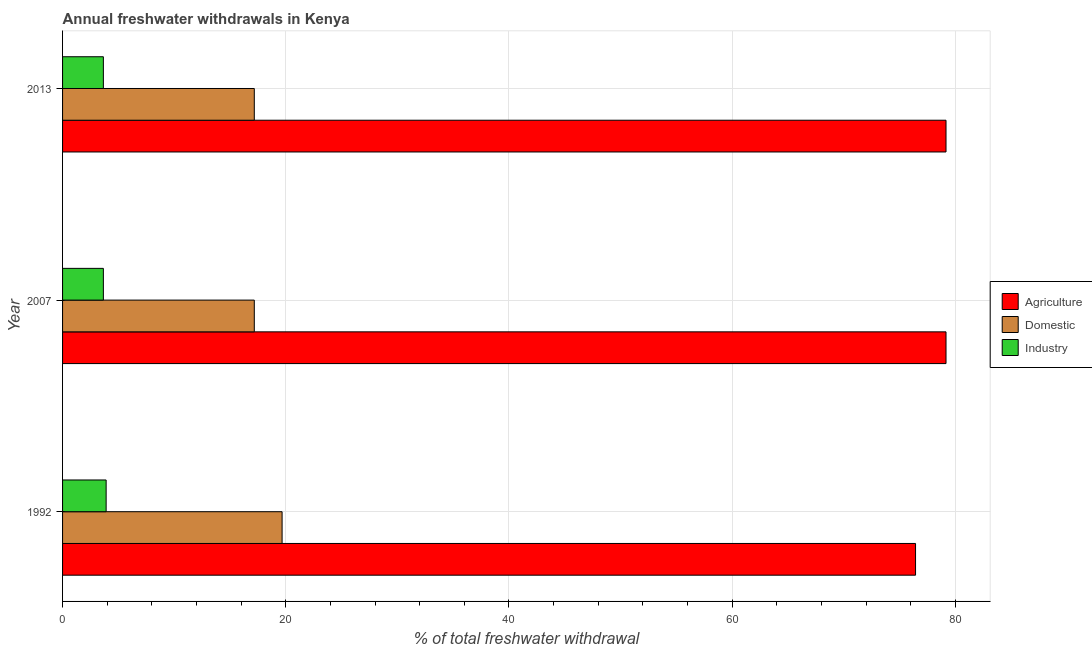Are the number of bars per tick equal to the number of legend labels?
Keep it short and to the point. Yes. Are the number of bars on each tick of the Y-axis equal?
Offer a terse response. Yes. How many bars are there on the 3rd tick from the top?
Provide a succinct answer. 3. How many bars are there on the 3rd tick from the bottom?
Provide a short and direct response. 3. What is the label of the 2nd group of bars from the top?
Your answer should be very brief. 2007. In how many cases, is the number of bars for a given year not equal to the number of legend labels?
Offer a terse response. 0. What is the percentage of freshwater withdrawal for industry in 2013?
Make the answer very short. 3.66. Across all years, what is the maximum percentage of freshwater withdrawal for agriculture?
Provide a short and direct response. 79.16. Across all years, what is the minimum percentage of freshwater withdrawal for agriculture?
Keep it short and to the point. 76.43. In which year was the percentage of freshwater withdrawal for domestic purposes minimum?
Make the answer very short. 2007. What is the total percentage of freshwater withdrawal for domestic purposes in the graph?
Your answer should be compact. 54.03. What is the difference between the percentage of freshwater withdrawal for industry in 1992 and that in 2007?
Provide a succinct answer. 0.25. What is the difference between the percentage of freshwater withdrawal for domestic purposes in 1992 and the percentage of freshwater withdrawal for agriculture in 2007?
Give a very brief answer. -59.49. What is the average percentage of freshwater withdrawal for industry per year?
Keep it short and to the point. 3.74. In the year 1992, what is the difference between the percentage of freshwater withdrawal for industry and percentage of freshwater withdrawal for domestic purposes?
Ensure brevity in your answer.  -15.77. Is the difference between the percentage of freshwater withdrawal for domestic purposes in 1992 and 2007 greater than the difference between the percentage of freshwater withdrawal for industry in 1992 and 2007?
Your response must be concise. Yes. What is the difference between the highest and the second highest percentage of freshwater withdrawal for industry?
Provide a succinct answer. 0.25. What is the difference between the highest and the lowest percentage of freshwater withdrawal for domestic purposes?
Offer a terse response. 2.49. In how many years, is the percentage of freshwater withdrawal for domestic purposes greater than the average percentage of freshwater withdrawal for domestic purposes taken over all years?
Provide a short and direct response. 1. What does the 2nd bar from the top in 1992 represents?
Provide a short and direct response. Domestic. What does the 2nd bar from the bottom in 2013 represents?
Make the answer very short. Domestic. Are all the bars in the graph horizontal?
Offer a very short reply. Yes. Does the graph contain any zero values?
Give a very brief answer. No. Where does the legend appear in the graph?
Provide a succinct answer. Center right. How are the legend labels stacked?
Your response must be concise. Vertical. What is the title of the graph?
Ensure brevity in your answer.  Annual freshwater withdrawals in Kenya. Does "Industrial Nitrous Oxide" appear as one of the legend labels in the graph?
Keep it short and to the point. No. What is the label or title of the X-axis?
Ensure brevity in your answer.  % of total freshwater withdrawal. What is the % of total freshwater withdrawal of Agriculture in 1992?
Offer a very short reply. 76.43. What is the % of total freshwater withdrawal of Domestic in 1992?
Offer a terse response. 19.67. What is the % of total freshwater withdrawal in Industry in 1992?
Make the answer very short. 3.9. What is the % of total freshwater withdrawal in Agriculture in 2007?
Your response must be concise. 79.16. What is the % of total freshwater withdrawal of Domestic in 2007?
Give a very brief answer. 17.18. What is the % of total freshwater withdrawal of Industry in 2007?
Keep it short and to the point. 3.66. What is the % of total freshwater withdrawal of Agriculture in 2013?
Provide a short and direct response. 79.16. What is the % of total freshwater withdrawal in Domestic in 2013?
Your response must be concise. 17.18. What is the % of total freshwater withdrawal of Industry in 2013?
Offer a terse response. 3.66. Across all years, what is the maximum % of total freshwater withdrawal in Agriculture?
Offer a very short reply. 79.16. Across all years, what is the maximum % of total freshwater withdrawal in Domestic?
Ensure brevity in your answer.  19.67. Across all years, what is the maximum % of total freshwater withdrawal of Industry?
Give a very brief answer. 3.9. Across all years, what is the minimum % of total freshwater withdrawal of Agriculture?
Provide a short and direct response. 76.43. Across all years, what is the minimum % of total freshwater withdrawal of Domestic?
Ensure brevity in your answer.  17.18. Across all years, what is the minimum % of total freshwater withdrawal of Industry?
Offer a very short reply. 3.66. What is the total % of total freshwater withdrawal in Agriculture in the graph?
Offer a very short reply. 234.75. What is the total % of total freshwater withdrawal of Domestic in the graph?
Keep it short and to the point. 54.03. What is the total % of total freshwater withdrawal of Industry in the graph?
Keep it short and to the point. 11.22. What is the difference between the % of total freshwater withdrawal of Agriculture in 1992 and that in 2007?
Offer a terse response. -2.73. What is the difference between the % of total freshwater withdrawal of Domestic in 1992 and that in 2007?
Provide a succinct answer. 2.49. What is the difference between the % of total freshwater withdrawal of Industry in 1992 and that in 2007?
Your answer should be very brief. 0.25. What is the difference between the % of total freshwater withdrawal of Agriculture in 1992 and that in 2013?
Keep it short and to the point. -2.73. What is the difference between the % of total freshwater withdrawal of Domestic in 1992 and that in 2013?
Give a very brief answer. 2.49. What is the difference between the % of total freshwater withdrawal of Industry in 1992 and that in 2013?
Give a very brief answer. 0.25. What is the difference between the % of total freshwater withdrawal of Agriculture in 2007 and that in 2013?
Your response must be concise. 0. What is the difference between the % of total freshwater withdrawal of Domestic in 2007 and that in 2013?
Provide a short and direct response. 0. What is the difference between the % of total freshwater withdrawal of Agriculture in 1992 and the % of total freshwater withdrawal of Domestic in 2007?
Make the answer very short. 59.25. What is the difference between the % of total freshwater withdrawal in Agriculture in 1992 and the % of total freshwater withdrawal in Industry in 2007?
Provide a succinct answer. 72.77. What is the difference between the % of total freshwater withdrawal of Domestic in 1992 and the % of total freshwater withdrawal of Industry in 2007?
Provide a short and direct response. 16.01. What is the difference between the % of total freshwater withdrawal of Agriculture in 1992 and the % of total freshwater withdrawal of Domestic in 2013?
Your answer should be compact. 59.25. What is the difference between the % of total freshwater withdrawal of Agriculture in 1992 and the % of total freshwater withdrawal of Industry in 2013?
Your answer should be compact. 72.77. What is the difference between the % of total freshwater withdrawal in Domestic in 1992 and the % of total freshwater withdrawal in Industry in 2013?
Your response must be concise. 16.01. What is the difference between the % of total freshwater withdrawal of Agriculture in 2007 and the % of total freshwater withdrawal of Domestic in 2013?
Ensure brevity in your answer.  61.98. What is the difference between the % of total freshwater withdrawal in Agriculture in 2007 and the % of total freshwater withdrawal in Industry in 2013?
Offer a very short reply. 75.5. What is the difference between the % of total freshwater withdrawal of Domestic in 2007 and the % of total freshwater withdrawal of Industry in 2013?
Your answer should be compact. 13.52. What is the average % of total freshwater withdrawal of Agriculture per year?
Provide a succinct answer. 78.25. What is the average % of total freshwater withdrawal in Domestic per year?
Provide a succinct answer. 18.01. What is the average % of total freshwater withdrawal in Industry per year?
Give a very brief answer. 3.74. In the year 1992, what is the difference between the % of total freshwater withdrawal in Agriculture and % of total freshwater withdrawal in Domestic?
Keep it short and to the point. 56.76. In the year 1992, what is the difference between the % of total freshwater withdrawal in Agriculture and % of total freshwater withdrawal in Industry?
Make the answer very short. 72.53. In the year 1992, what is the difference between the % of total freshwater withdrawal of Domestic and % of total freshwater withdrawal of Industry?
Give a very brief answer. 15.77. In the year 2007, what is the difference between the % of total freshwater withdrawal of Agriculture and % of total freshwater withdrawal of Domestic?
Ensure brevity in your answer.  61.98. In the year 2007, what is the difference between the % of total freshwater withdrawal of Agriculture and % of total freshwater withdrawal of Industry?
Provide a succinct answer. 75.5. In the year 2007, what is the difference between the % of total freshwater withdrawal of Domestic and % of total freshwater withdrawal of Industry?
Your answer should be very brief. 13.52. In the year 2013, what is the difference between the % of total freshwater withdrawal in Agriculture and % of total freshwater withdrawal in Domestic?
Make the answer very short. 61.98. In the year 2013, what is the difference between the % of total freshwater withdrawal in Agriculture and % of total freshwater withdrawal in Industry?
Provide a short and direct response. 75.5. In the year 2013, what is the difference between the % of total freshwater withdrawal in Domestic and % of total freshwater withdrawal in Industry?
Make the answer very short. 13.52. What is the ratio of the % of total freshwater withdrawal of Agriculture in 1992 to that in 2007?
Provide a succinct answer. 0.97. What is the ratio of the % of total freshwater withdrawal in Domestic in 1992 to that in 2007?
Make the answer very short. 1.14. What is the ratio of the % of total freshwater withdrawal of Industry in 1992 to that in 2007?
Offer a very short reply. 1.07. What is the ratio of the % of total freshwater withdrawal in Agriculture in 1992 to that in 2013?
Your response must be concise. 0.97. What is the ratio of the % of total freshwater withdrawal in Domestic in 1992 to that in 2013?
Your answer should be very brief. 1.14. What is the ratio of the % of total freshwater withdrawal in Industry in 1992 to that in 2013?
Give a very brief answer. 1.07. What is the ratio of the % of total freshwater withdrawal of Agriculture in 2007 to that in 2013?
Your response must be concise. 1. What is the ratio of the % of total freshwater withdrawal of Domestic in 2007 to that in 2013?
Make the answer very short. 1. What is the ratio of the % of total freshwater withdrawal of Industry in 2007 to that in 2013?
Offer a terse response. 1. What is the difference between the highest and the second highest % of total freshwater withdrawal of Agriculture?
Ensure brevity in your answer.  0. What is the difference between the highest and the second highest % of total freshwater withdrawal in Domestic?
Provide a short and direct response. 2.49. What is the difference between the highest and the second highest % of total freshwater withdrawal in Industry?
Your answer should be very brief. 0.25. What is the difference between the highest and the lowest % of total freshwater withdrawal of Agriculture?
Make the answer very short. 2.73. What is the difference between the highest and the lowest % of total freshwater withdrawal in Domestic?
Your response must be concise. 2.49. What is the difference between the highest and the lowest % of total freshwater withdrawal in Industry?
Make the answer very short. 0.25. 